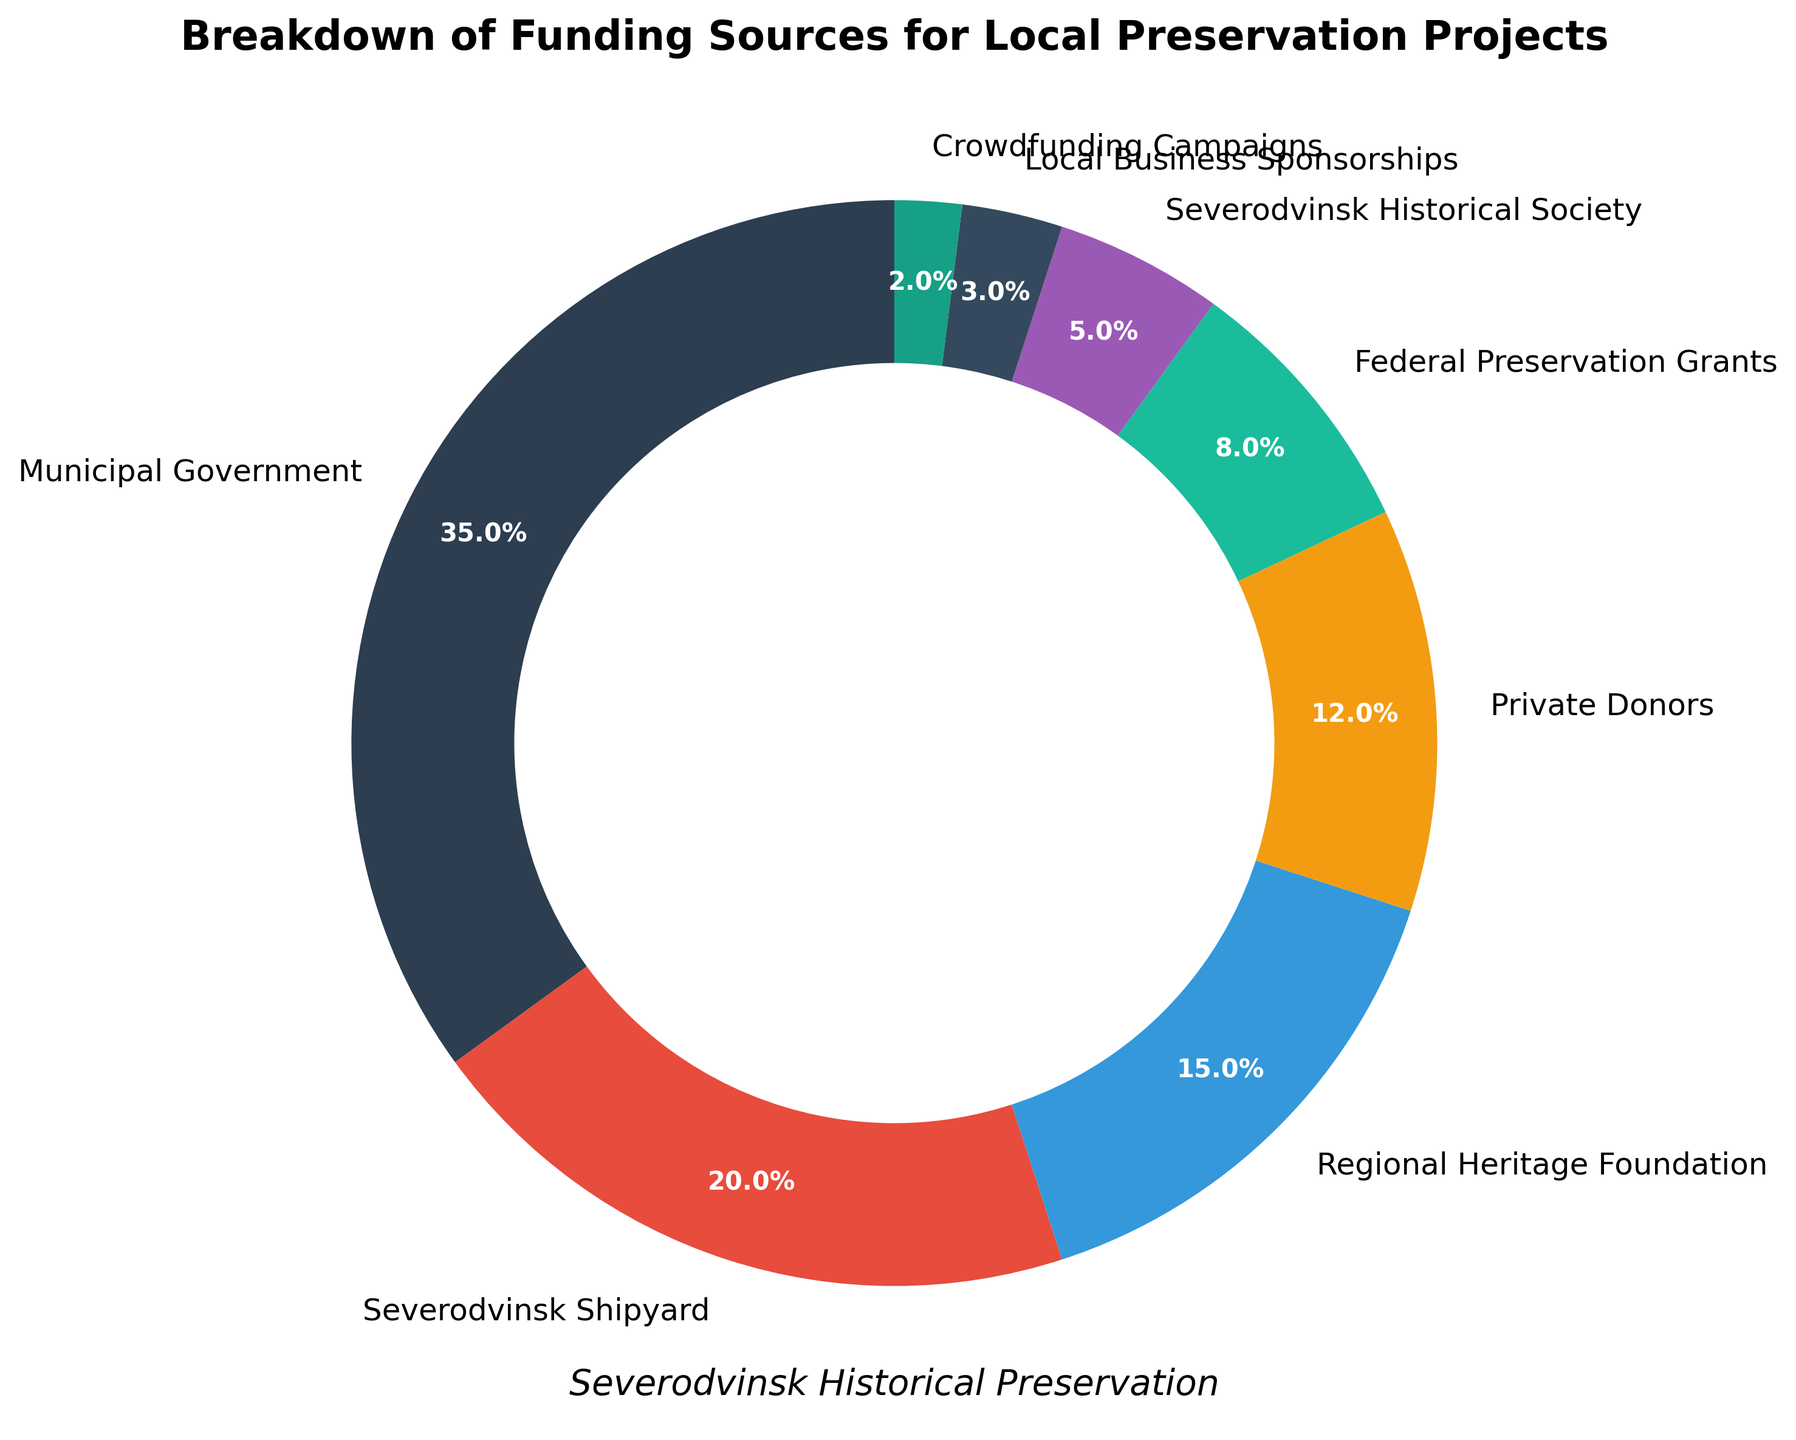What is the largest source of funding for local preservation projects? The pie chart shows various funding sources, with the Municipal Government contributing the largest percentage at 35%.
Answer: Municipal Government Which funding sources contribute less than 10% each? By looking at the pie chart, the sources contributing less than 10% are Federal Preservation Grants (8%), Severodvinsk Historical Society (5%), Local Business Sponsorships (3%), and Crowdfunding Campaigns (2%).
Answer: Federal Preservation Grants, Severodvinsk Historical Society, Local Business Sponsorships, Crowdfunding Campaigns How much more funding does the Severodvinsk Shipyard provide compared to Private Donors? Severodvinsk Shipyard contributes 20%, whereas Private Donors contribute 12%. The difference is calculated as 20% - 12% = 8%.
Answer: 8% If we combine the contributions from the Severodvinsk Historical Society and Crowdfunding Campaigns, what is their total percentage? The Severodvinsk Historical Society contributes 5% and Crowdfunding Campaigns contribute 2%. Adding these gives 5% + 2% = 7%.
Answer: 7% Which two funding sources contribute equally to local preservation projects? The pie chart reveals that no two funding sources contribute the same percentage, so there are no two funding sources that contribute equally.
Answer: None How does the funding from Private Donors compare to the funding from Regional Heritage Foundation? Private Donors contribute 12%, whereas the Regional Heritage Foundation contributes 15%. Therefore, the Regional Heritage Foundation provides more funding than Private Donors.
Answer: Regional Heritage Foundation provides more What are the sources contributing more than 20% combined excluding the largest source? Excluding the largest source (Municipal Government at 35%), we look for sources contributing more than 20% together. Severodvinsk Shipyard (20%) alone meets this criterion.
Answer: Severodvinsk Shipyard If the funding from Local Business Sponsorships were doubled, how would its total percentage change in the chart? Local Business Sponsorships currently contribute 3%. If doubled, it would contribute 3% * 2 = 6%.
Answer: 6% What is the total percentage contributed by sources related to local organizations (excluding government sources)? Adding the percentages from Severodvinsk Shipyard (20%), Private Donors (12%), Severodvinsk Historical Society (5%), Local Business Sponsorships (3%), and Crowdfunding Campaigns (2%) results in a total of 20% + 12% + 5% + 3% + 2% = 42%.
Answer: 42% What funding source uses a dark blue color in the pie chart? The funding source represented by the dark blue color is Severodvinsk Shipyard.
Answer: Severodvinsk Shipyard 